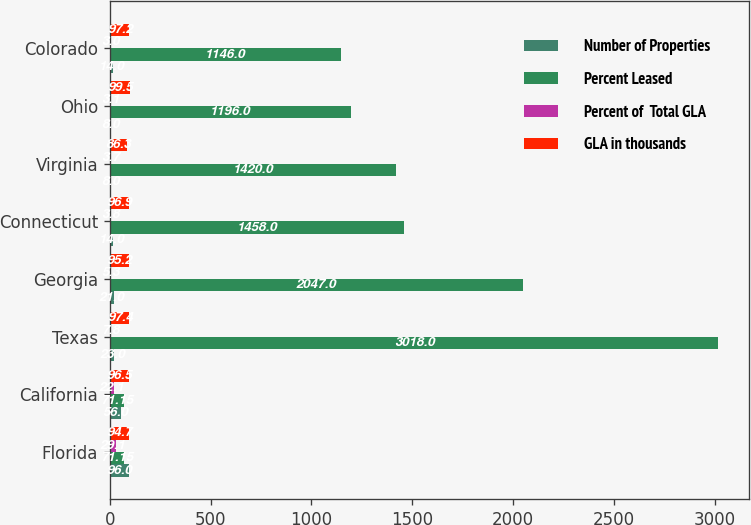<chart> <loc_0><loc_0><loc_500><loc_500><stacked_bar_chart><ecel><fcel>Florida<fcel>California<fcel>Texas<fcel>Georgia<fcel>Connecticut<fcel>Virginia<fcel>Ohio<fcel>Colorado<nl><fcel>Number of Properties<fcel>96<fcel>56<fcel>23<fcel>21<fcel>14<fcel>8<fcel>8<fcel>14<nl><fcel>Percent Leased<fcel>71.15<fcel>71.15<fcel>3018<fcel>2047<fcel>1458<fcel>1420<fcel>1196<fcel>1146<nl><fcel>Percent of  Total GLA<fcel>29.1<fcel>22.1<fcel>7.8<fcel>5.3<fcel>3.8<fcel>3.7<fcel>3.1<fcel>3<nl><fcel>GLA in thousands<fcel>94.7<fcel>96.5<fcel>97.4<fcel>95.2<fcel>96.9<fcel>86.3<fcel>99.5<fcel>97.2<nl></chart> 